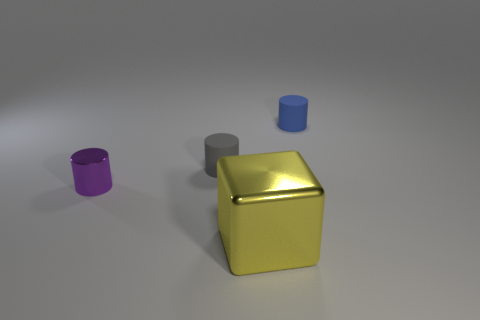Is there any other thing that has the same size as the block?
Offer a terse response. No. There is a cylinder to the right of the object in front of the metal cylinder; how big is it?
Your response must be concise. Small. What number of cylinders are either small blue rubber objects or small matte objects?
Your answer should be very brief. 2. There is a matte thing that is the same size as the blue cylinder; what color is it?
Your answer should be very brief. Gray. The thing that is to the right of the metal thing that is in front of the tiny metallic object is what shape?
Provide a short and direct response. Cylinder. Does the shiny thing left of the yellow cube have the same size as the cube?
Make the answer very short. No. How many other objects are the same material as the yellow object?
Your response must be concise. 1. How many brown things are shiny blocks or cylinders?
Your response must be concise. 0. There is a large thing; what number of small gray cylinders are on the right side of it?
Make the answer very short. 0. What is the size of the shiny object behind the metallic thing in front of the tiny object that is left of the gray cylinder?
Your answer should be compact. Small. 